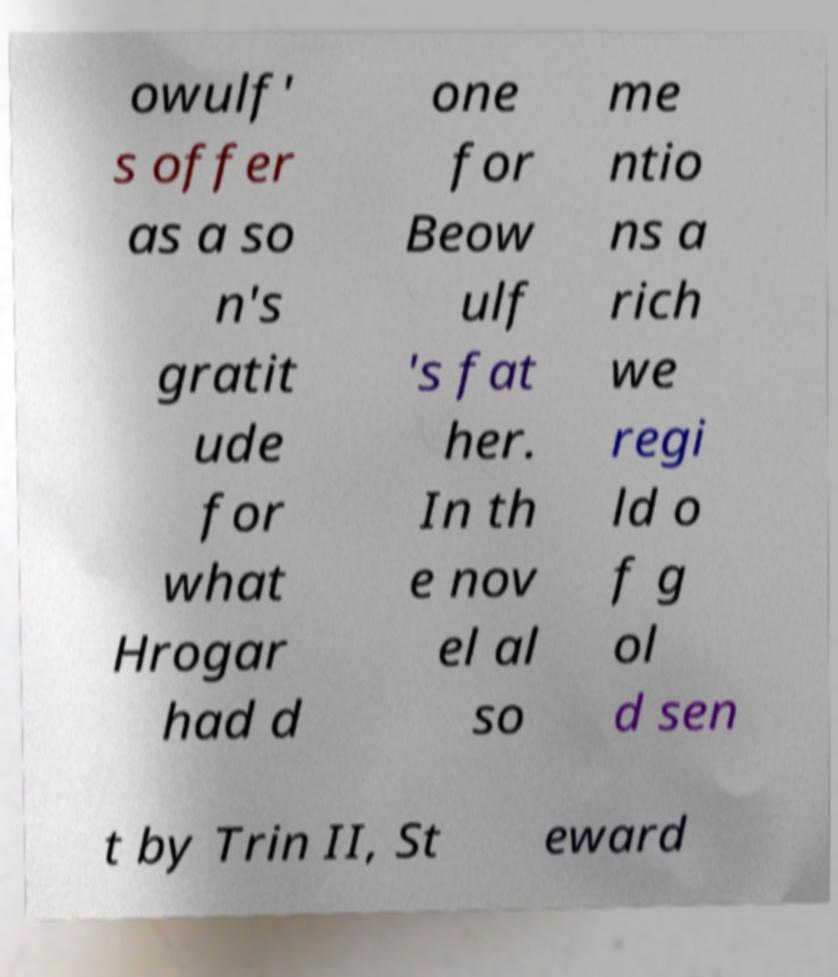Could you extract and type out the text from this image? owulf' s offer as a so n's gratit ude for what Hrogar had d one for Beow ulf 's fat her. In th e nov el al so me ntio ns a rich we regi ld o f g ol d sen t by Trin II, St eward 